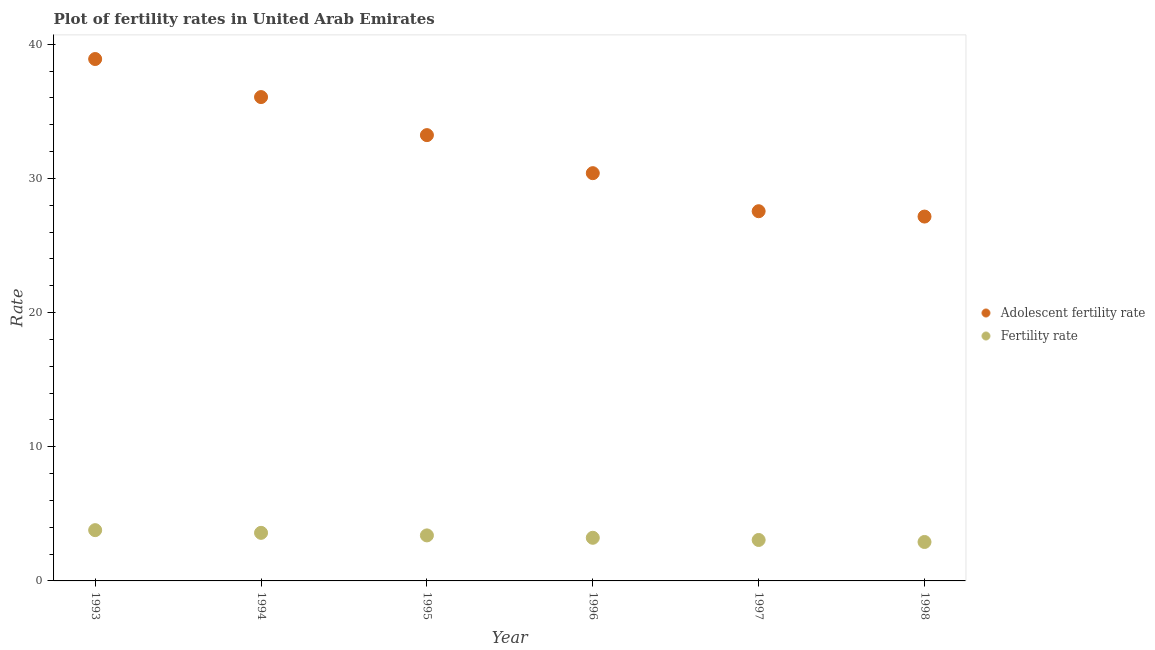What is the adolescent fertility rate in 1997?
Offer a terse response. 27.55. Across all years, what is the maximum fertility rate?
Your response must be concise. 3.78. Across all years, what is the minimum adolescent fertility rate?
Offer a terse response. 27.16. In which year was the fertility rate minimum?
Ensure brevity in your answer.  1998. What is the total adolescent fertility rate in the graph?
Give a very brief answer. 193.28. What is the difference between the fertility rate in 1994 and that in 1997?
Make the answer very short. 0.53. What is the difference between the fertility rate in 1997 and the adolescent fertility rate in 1996?
Your answer should be very brief. -27.34. What is the average fertility rate per year?
Your answer should be very brief. 3.32. In the year 1995, what is the difference between the fertility rate and adolescent fertility rate?
Keep it short and to the point. -29.83. What is the ratio of the adolescent fertility rate in 1993 to that in 1995?
Offer a terse response. 1.17. Is the adolescent fertility rate in 1993 less than that in 1994?
Provide a short and direct response. No. What is the difference between the highest and the second highest fertility rate?
Offer a very short reply. 0.2. What is the difference between the highest and the lowest fertility rate?
Your answer should be compact. 0.88. In how many years, is the fertility rate greater than the average fertility rate taken over all years?
Offer a very short reply. 3. Is the sum of the fertility rate in 1994 and 1997 greater than the maximum adolescent fertility rate across all years?
Your answer should be very brief. No. What is the difference between two consecutive major ticks on the Y-axis?
Your answer should be compact. 10. How are the legend labels stacked?
Provide a short and direct response. Vertical. What is the title of the graph?
Offer a very short reply. Plot of fertility rates in United Arab Emirates. What is the label or title of the X-axis?
Give a very brief answer. Year. What is the label or title of the Y-axis?
Offer a terse response. Rate. What is the Rate in Adolescent fertility rate in 1993?
Keep it short and to the point. 38.9. What is the Rate of Fertility rate in 1993?
Your answer should be compact. 3.78. What is the Rate of Adolescent fertility rate in 1994?
Provide a succinct answer. 36.06. What is the Rate of Fertility rate in 1994?
Give a very brief answer. 3.58. What is the Rate of Adolescent fertility rate in 1995?
Provide a short and direct response. 33.23. What is the Rate of Fertility rate in 1995?
Your answer should be very brief. 3.39. What is the Rate in Adolescent fertility rate in 1996?
Make the answer very short. 30.39. What is the Rate in Fertility rate in 1996?
Your answer should be very brief. 3.21. What is the Rate in Adolescent fertility rate in 1997?
Provide a short and direct response. 27.55. What is the Rate in Fertility rate in 1997?
Keep it short and to the point. 3.05. What is the Rate of Adolescent fertility rate in 1998?
Your response must be concise. 27.16. What is the Rate of Fertility rate in 1998?
Offer a very short reply. 2.9. Across all years, what is the maximum Rate of Adolescent fertility rate?
Keep it short and to the point. 38.9. Across all years, what is the maximum Rate of Fertility rate?
Your answer should be very brief. 3.78. Across all years, what is the minimum Rate in Adolescent fertility rate?
Offer a very short reply. 27.16. Across all years, what is the minimum Rate of Fertility rate?
Your answer should be very brief. 2.9. What is the total Rate of Adolescent fertility rate in the graph?
Make the answer very short. 193.28. What is the total Rate in Fertility rate in the graph?
Provide a succinct answer. 19.93. What is the difference between the Rate in Adolescent fertility rate in 1993 and that in 1994?
Give a very brief answer. 2.84. What is the difference between the Rate in Fertility rate in 1993 and that in 1994?
Keep it short and to the point. 0.2. What is the difference between the Rate in Adolescent fertility rate in 1993 and that in 1995?
Offer a very short reply. 5.67. What is the difference between the Rate of Fertility rate in 1993 and that in 1995?
Keep it short and to the point. 0.39. What is the difference between the Rate of Adolescent fertility rate in 1993 and that in 1996?
Ensure brevity in your answer.  8.51. What is the difference between the Rate in Fertility rate in 1993 and that in 1996?
Your response must be concise. 0.57. What is the difference between the Rate of Adolescent fertility rate in 1993 and that in 1997?
Your answer should be compact. 11.34. What is the difference between the Rate of Fertility rate in 1993 and that in 1997?
Give a very brief answer. 0.73. What is the difference between the Rate of Adolescent fertility rate in 1993 and that in 1998?
Make the answer very short. 11.74. What is the difference between the Rate of Fertility rate in 1993 and that in 1998?
Your response must be concise. 0.88. What is the difference between the Rate of Adolescent fertility rate in 1994 and that in 1995?
Your answer should be very brief. 2.84. What is the difference between the Rate of Fertility rate in 1994 and that in 1995?
Give a very brief answer. 0.19. What is the difference between the Rate of Adolescent fertility rate in 1994 and that in 1996?
Offer a very short reply. 5.67. What is the difference between the Rate of Fertility rate in 1994 and that in 1996?
Ensure brevity in your answer.  0.37. What is the difference between the Rate in Adolescent fertility rate in 1994 and that in 1997?
Your answer should be very brief. 8.51. What is the difference between the Rate in Fertility rate in 1994 and that in 1997?
Offer a very short reply. 0.53. What is the difference between the Rate of Adolescent fertility rate in 1994 and that in 1998?
Give a very brief answer. 8.91. What is the difference between the Rate of Fertility rate in 1994 and that in 1998?
Your answer should be compact. 0.68. What is the difference between the Rate in Adolescent fertility rate in 1995 and that in 1996?
Provide a succinct answer. 2.84. What is the difference between the Rate in Fertility rate in 1995 and that in 1996?
Ensure brevity in your answer.  0.18. What is the difference between the Rate of Adolescent fertility rate in 1995 and that in 1997?
Keep it short and to the point. 5.67. What is the difference between the Rate in Fertility rate in 1995 and that in 1997?
Provide a short and direct response. 0.34. What is the difference between the Rate in Adolescent fertility rate in 1995 and that in 1998?
Ensure brevity in your answer.  6.07. What is the difference between the Rate of Fertility rate in 1995 and that in 1998?
Keep it short and to the point. 0.49. What is the difference between the Rate in Adolescent fertility rate in 1996 and that in 1997?
Your answer should be very brief. 2.84. What is the difference between the Rate of Fertility rate in 1996 and that in 1997?
Make the answer very short. 0.16. What is the difference between the Rate of Adolescent fertility rate in 1996 and that in 1998?
Keep it short and to the point. 3.23. What is the difference between the Rate of Fertility rate in 1996 and that in 1998?
Offer a very short reply. 0.31. What is the difference between the Rate of Adolescent fertility rate in 1997 and that in 1998?
Your response must be concise. 0.4. What is the difference between the Rate in Fertility rate in 1997 and that in 1998?
Ensure brevity in your answer.  0.15. What is the difference between the Rate of Adolescent fertility rate in 1993 and the Rate of Fertility rate in 1994?
Offer a terse response. 35.31. What is the difference between the Rate in Adolescent fertility rate in 1993 and the Rate in Fertility rate in 1995?
Provide a short and direct response. 35.5. What is the difference between the Rate in Adolescent fertility rate in 1993 and the Rate in Fertility rate in 1996?
Ensure brevity in your answer.  35.68. What is the difference between the Rate of Adolescent fertility rate in 1993 and the Rate of Fertility rate in 1997?
Provide a succinct answer. 35.85. What is the difference between the Rate in Adolescent fertility rate in 1993 and the Rate in Fertility rate in 1998?
Your answer should be very brief. 36. What is the difference between the Rate in Adolescent fertility rate in 1994 and the Rate in Fertility rate in 1995?
Keep it short and to the point. 32.67. What is the difference between the Rate of Adolescent fertility rate in 1994 and the Rate of Fertility rate in 1996?
Offer a terse response. 32.85. What is the difference between the Rate in Adolescent fertility rate in 1994 and the Rate in Fertility rate in 1997?
Provide a succinct answer. 33.01. What is the difference between the Rate of Adolescent fertility rate in 1994 and the Rate of Fertility rate in 1998?
Ensure brevity in your answer.  33.16. What is the difference between the Rate of Adolescent fertility rate in 1995 and the Rate of Fertility rate in 1996?
Offer a terse response. 30.01. What is the difference between the Rate in Adolescent fertility rate in 1995 and the Rate in Fertility rate in 1997?
Keep it short and to the point. 30.17. What is the difference between the Rate of Adolescent fertility rate in 1995 and the Rate of Fertility rate in 1998?
Offer a very short reply. 30.32. What is the difference between the Rate in Adolescent fertility rate in 1996 and the Rate in Fertility rate in 1997?
Your answer should be compact. 27.34. What is the difference between the Rate of Adolescent fertility rate in 1996 and the Rate of Fertility rate in 1998?
Make the answer very short. 27.49. What is the difference between the Rate in Adolescent fertility rate in 1997 and the Rate in Fertility rate in 1998?
Provide a succinct answer. 24.65. What is the average Rate of Adolescent fertility rate per year?
Provide a succinct answer. 32.21. What is the average Rate of Fertility rate per year?
Provide a succinct answer. 3.32. In the year 1993, what is the difference between the Rate of Adolescent fertility rate and Rate of Fertility rate?
Keep it short and to the point. 35.11. In the year 1994, what is the difference between the Rate of Adolescent fertility rate and Rate of Fertility rate?
Offer a terse response. 32.48. In the year 1995, what is the difference between the Rate in Adolescent fertility rate and Rate in Fertility rate?
Offer a very short reply. 29.83. In the year 1996, what is the difference between the Rate in Adolescent fertility rate and Rate in Fertility rate?
Your answer should be compact. 27.17. In the year 1997, what is the difference between the Rate in Adolescent fertility rate and Rate in Fertility rate?
Your answer should be compact. 24.5. In the year 1998, what is the difference between the Rate of Adolescent fertility rate and Rate of Fertility rate?
Provide a succinct answer. 24.25. What is the ratio of the Rate in Adolescent fertility rate in 1993 to that in 1994?
Offer a very short reply. 1.08. What is the ratio of the Rate of Fertility rate in 1993 to that in 1994?
Your answer should be very brief. 1.06. What is the ratio of the Rate of Adolescent fertility rate in 1993 to that in 1995?
Your response must be concise. 1.17. What is the ratio of the Rate of Fertility rate in 1993 to that in 1995?
Offer a very short reply. 1.12. What is the ratio of the Rate of Adolescent fertility rate in 1993 to that in 1996?
Provide a short and direct response. 1.28. What is the ratio of the Rate in Fertility rate in 1993 to that in 1996?
Offer a very short reply. 1.18. What is the ratio of the Rate in Adolescent fertility rate in 1993 to that in 1997?
Your answer should be compact. 1.41. What is the ratio of the Rate of Fertility rate in 1993 to that in 1997?
Ensure brevity in your answer.  1.24. What is the ratio of the Rate of Adolescent fertility rate in 1993 to that in 1998?
Provide a succinct answer. 1.43. What is the ratio of the Rate in Fertility rate in 1993 to that in 1998?
Provide a succinct answer. 1.3. What is the ratio of the Rate of Adolescent fertility rate in 1994 to that in 1995?
Provide a short and direct response. 1.09. What is the ratio of the Rate in Fertility rate in 1994 to that in 1995?
Make the answer very short. 1.06. What is the ratio of the Rate in Adolescent fertility rate in 1994 to that in 1996?
Provide a short and direct response. 1.19. What is the ratio of the Rate of Fertility rate in 1994 to that in 1996?
Your answer should be compact. 1.11. What is the ratio of the Rate in Adolescent fertility rate in 1994 to that in 1997?
Keep it short and to the point. 1.31. What is the ratio of the Rate of Fertility rate in 1994 to that in 1997?
Keep it short and to the point. 1.17. What is the ratio of the Rate of Adolescent fertility rate in 1994 to that in 1998?
Provide a succinct answer. 1.33. What is the ratio of the Rate in Fertility rate in 1994 to that in 1998?
Make the answer very short. 1.23. What is the ratio of the Rate in Adolescent fertility rate in 1995 to that in 1996?
Your response must be concise. 1.09. What is the ratio of the Rate in Fertility rate in 1995 to that in 1996?
Offer a very short reply. 1.06. What is the ratio of the Rate of Adolescent fertility rate in 1995 to that in 1997?
Make the answer very short. 1.21. What is the ratio of the Rate in Fertility rate in 1995 to that in 1997?
Your answer should be compact. 1.11. What is the ratio of the Rate in Adolescent fertility rate in 1995 to that in 1998?
Your answer should be compact. 1.22. What is the ratio of the Rate in Fertility rate in 1995 to that in 1998?
Make the answer very short. 1.17. What is the ratio of the Rate of Adolescent fertility rate in 1996 to that in 1997?
Your answer should be compact. 1.1. What is the ratio of the Rate in Fertility rate in 1996 to that in 1997?
Offer a terse response. 1.05. What is the ratio of the Rate in Adolescent fertility rate in 1996 to that in 1998?
Provide a short and direct response. 1.12. What is the ratio of the Rate in Fertility rate in 1996 to that in 1998?
Your response must be concise. 1.11. What is the ratio of the Rate in Adolescent fertility rate in 1997 to that in 1998?
Ensure brevity in your answer.  1.01. What is the ratio of the Rate of Fertility rate in 1997 to that in 1998?
Make the answer very short. 1.05. What is the difference between the highest and the second highest Rate in Adolescent fertility rate?
Offer a very short reply. 2.84. What is the difference between the highest and the second highest Rate of Fertility rate?
Your answer should be very brief. 0.2. What is the difference between the highest and the lowest Rate of Adolescent fertility rate?
Provide a succinct answer. 11.74. What is the difference between the highest and the lowest Rate in Fertility rate?
Keep it short and to the point. 0.88. 